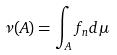Convert formula to latex. <formula><loc_0><loc_0><loc_500><loc_500>\nu ( A ) = \int _ { A } f _ { n } d \mu</formula> 